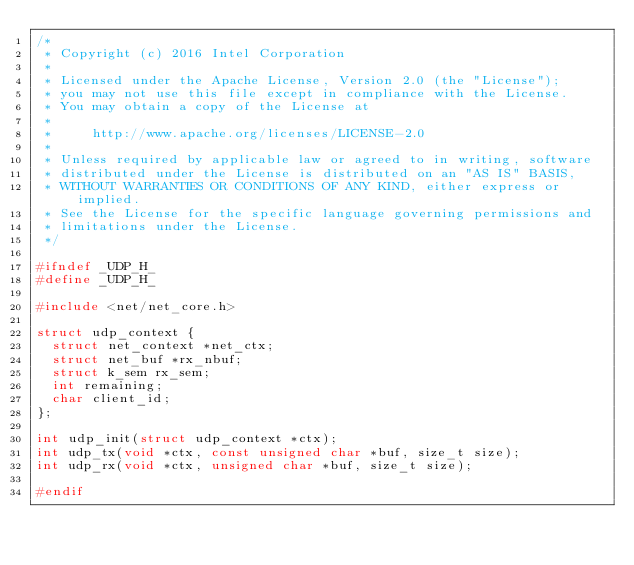Convert code to text. <code><loc_0><loc_0><loc_500><loc_500><_C_>/*
 * Copyright (c) 2016 Intel Corporation
 *
 * Licensed under the Apache License, Version 2.0 (the "License");
 * you may not use this file except in compliance with the License.
 * You may obtain a copy of the License at
 *
 *     http://www.apache.org/licenses/LICENSE-2.0
 *
 * Unless required by applicable law or agreed to in writing, software
 * distributed under the License is distributed on an "AS IS" BASIS,
 * WITHOUT WARRANTIES OR CONDITIONS OF ANY KIND, either express or implied.
 * See the License for the specific language governing permissions and
 * limitations under the License.
 */

#ifndef _UDP_H_
#define _UDP_H_

#include <net/net_core.h>

struct udp_context {
	struct net_context *net_ctx;
	struct net_buf *rx_nbuf;
	struct k_sem rx_sem;
	int remaining;
	char client_id;
};

int udp_init(struct udp_context *ctx);
int udp_tx(void *ctx, const unsigned char *buf, size_t size);
int udp_rx(void *ctx, unsigned char *buf, size_t size);

#endif
</code> 